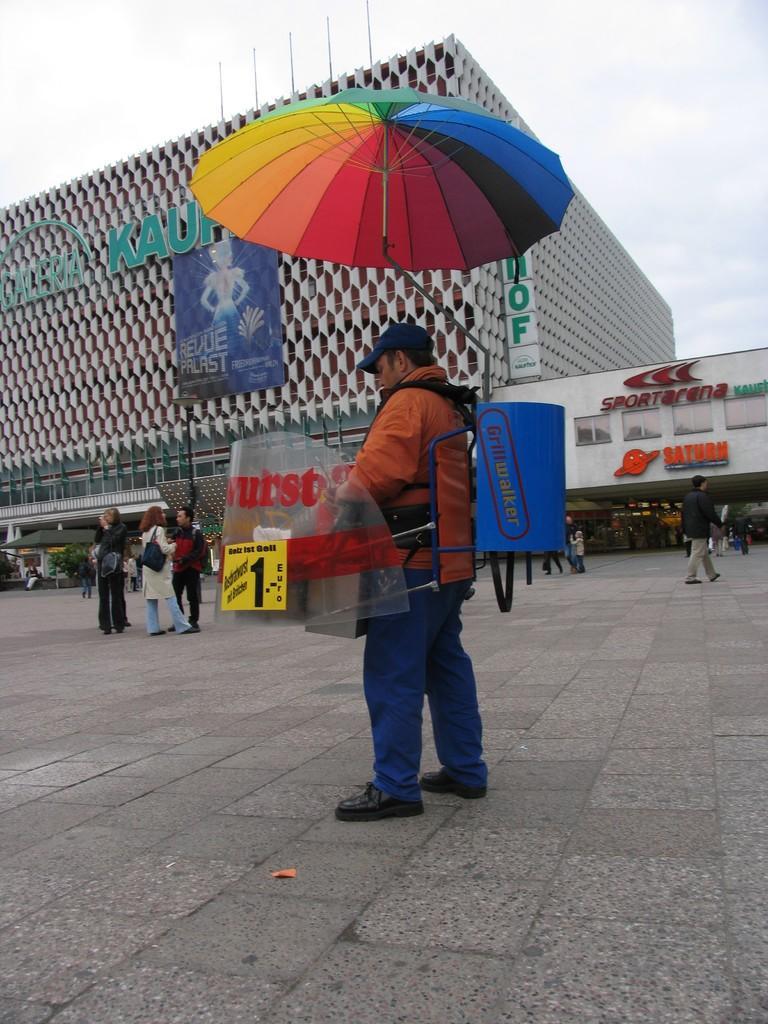Describe this image in one or two sentences. In this image we can see a person wearing yellow color jacket blue color jeans carrying umbrella and some tray standing on the ground and at the background of the image there are some persons standing there is building, showroom and clear sky. 